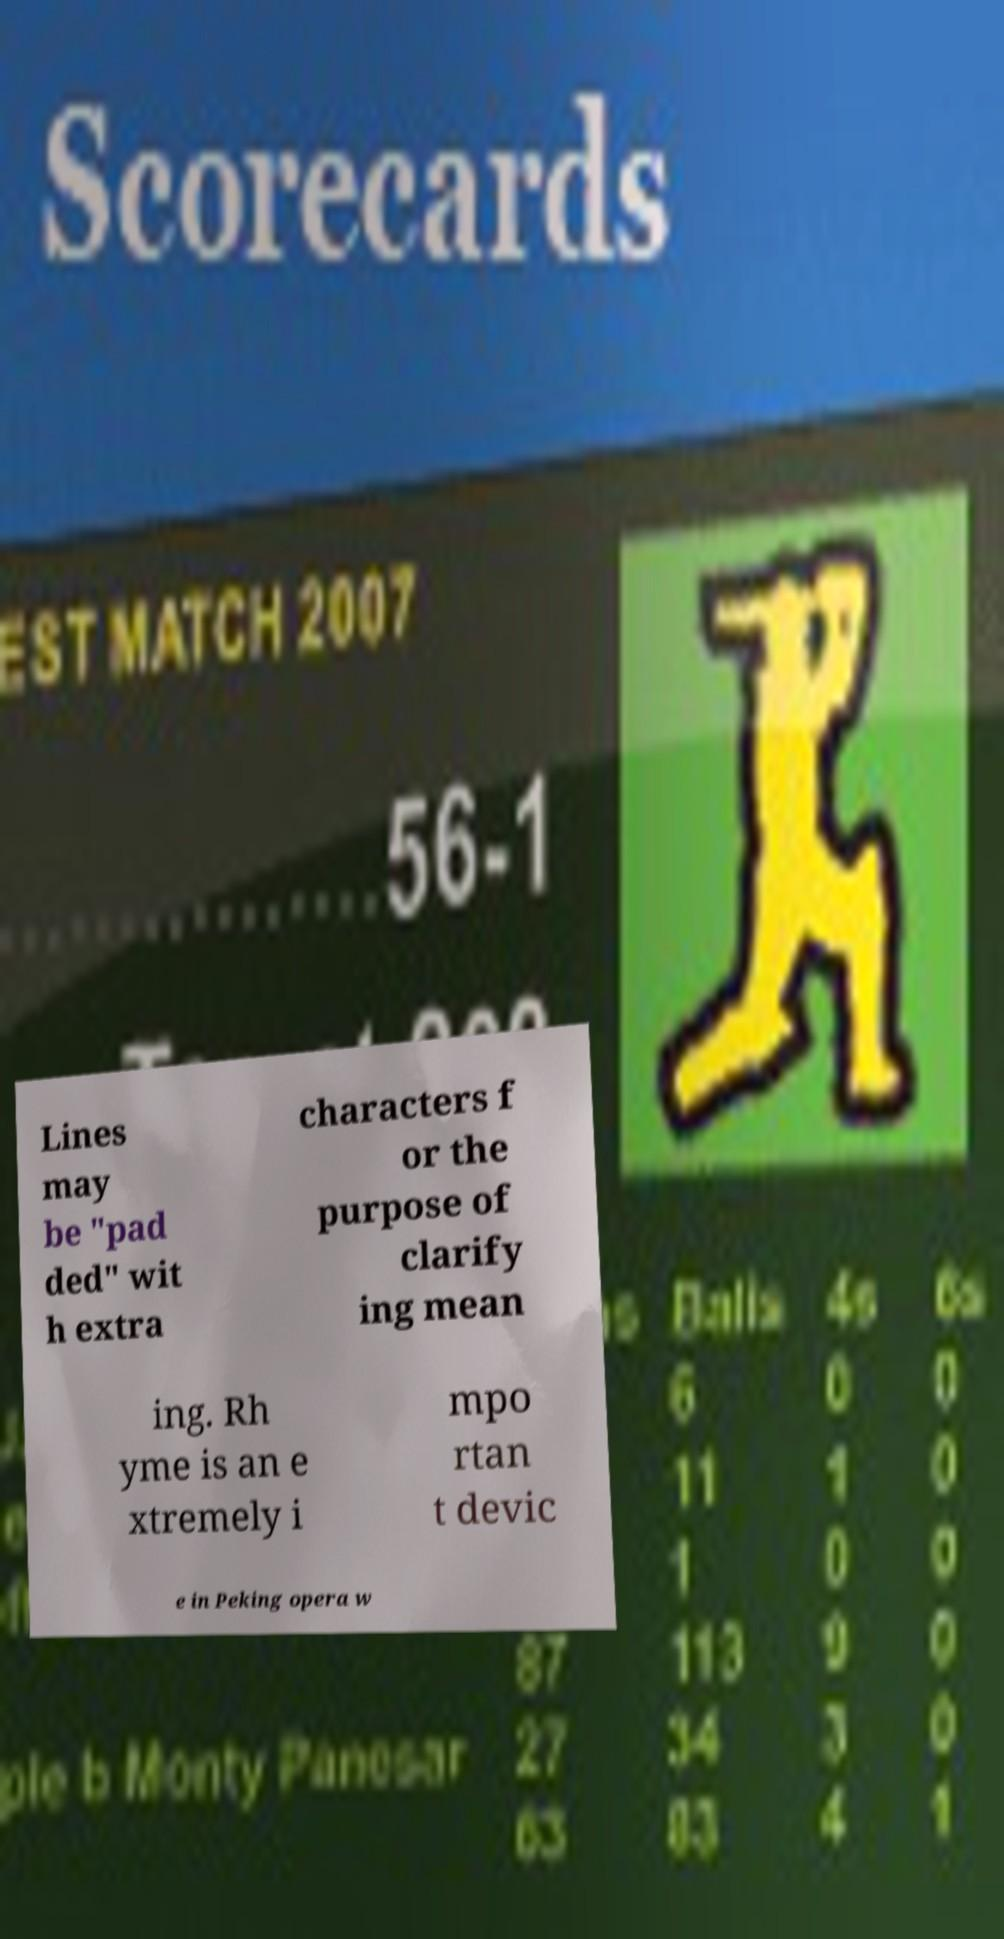What messages or text are displayed in this image? I need them in a readable, typed format. Lines may be "pad ded" wit h extra characters f or the purpose of clarify ing mean ing. Rh yme is an e xtremely i mpo rtan t devic e in Peking opera w 